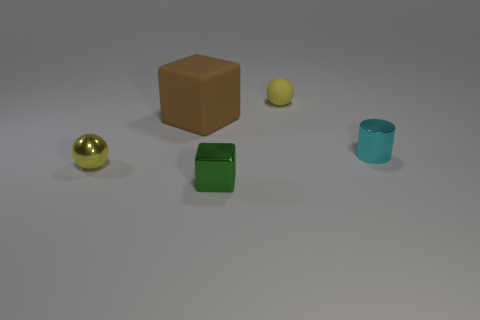Add 2 tiny cyan shiny objects. How many objects exist? 7 Subtract all brown cubes. How many cubes are left? 1 Subtract all balls. How many objects are left? 3 Subtract 1 cubes. How many cubes are left? 1 Subtract all yellow cylinders. How many green blocks are left? 1 Add 5 shiny cylinders. How many shiny cylinders are left? 6 Add 3 large blue metal blocks. How many large blue metal blocks exist? 3 Subtract 0 gray cylinders. How many objects are left? 5 Subtract all cyan spheres. Subtract all yellow cubes. How many spheres are left? 2 Subtract all big brown cubes. Subtract all shiny balls. How many objects are left? 3 